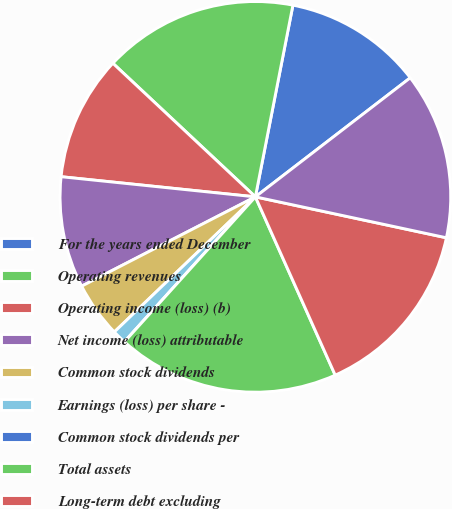Convert chart to OTSL. <chart><loc_0><loc_0><loc_500><loc_500><pie_chart><fcel>For the years ended December<fcel>Operating revenues<fcel>Operating income (loss) (b)<fcel>Net income (loss) attributable<fcel>Common stock dividends<fcel>Earnings (loss) per share -<fcel>Common stock dividends per<fcel>Total assets<fcel>Long-term debt excluding<fcel>Total Ameren Corporation<nl><fcel>11.49%<fcel>16.09%<fcel>10.34%<fcel>9.2%<fcel>4.6%<fcel>1.15%<fcel>0.0%<fcel>18.39%<fcel>14.94%<fcel>13.79%<nl></chart> 